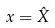<formula> <loc_0><loc_0><loc_500><loc_500>x = \hat { X }</formula> 